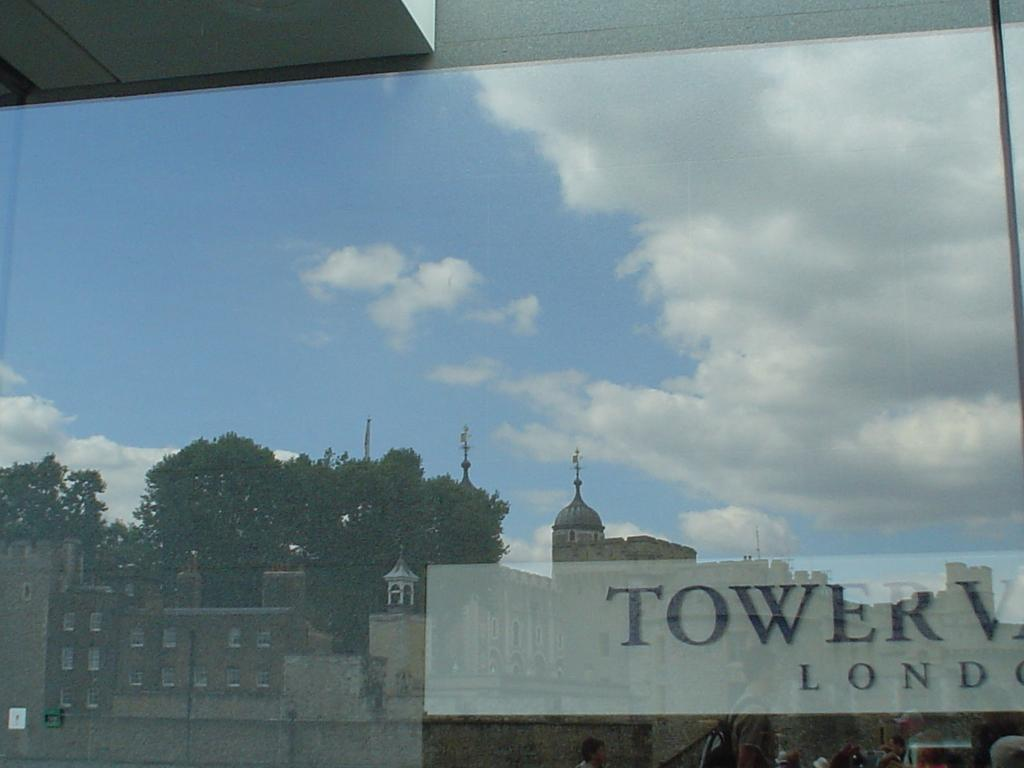<image>
Create a compact narrative representing the image presented. A window is reflecting a city building that says Tower London. 